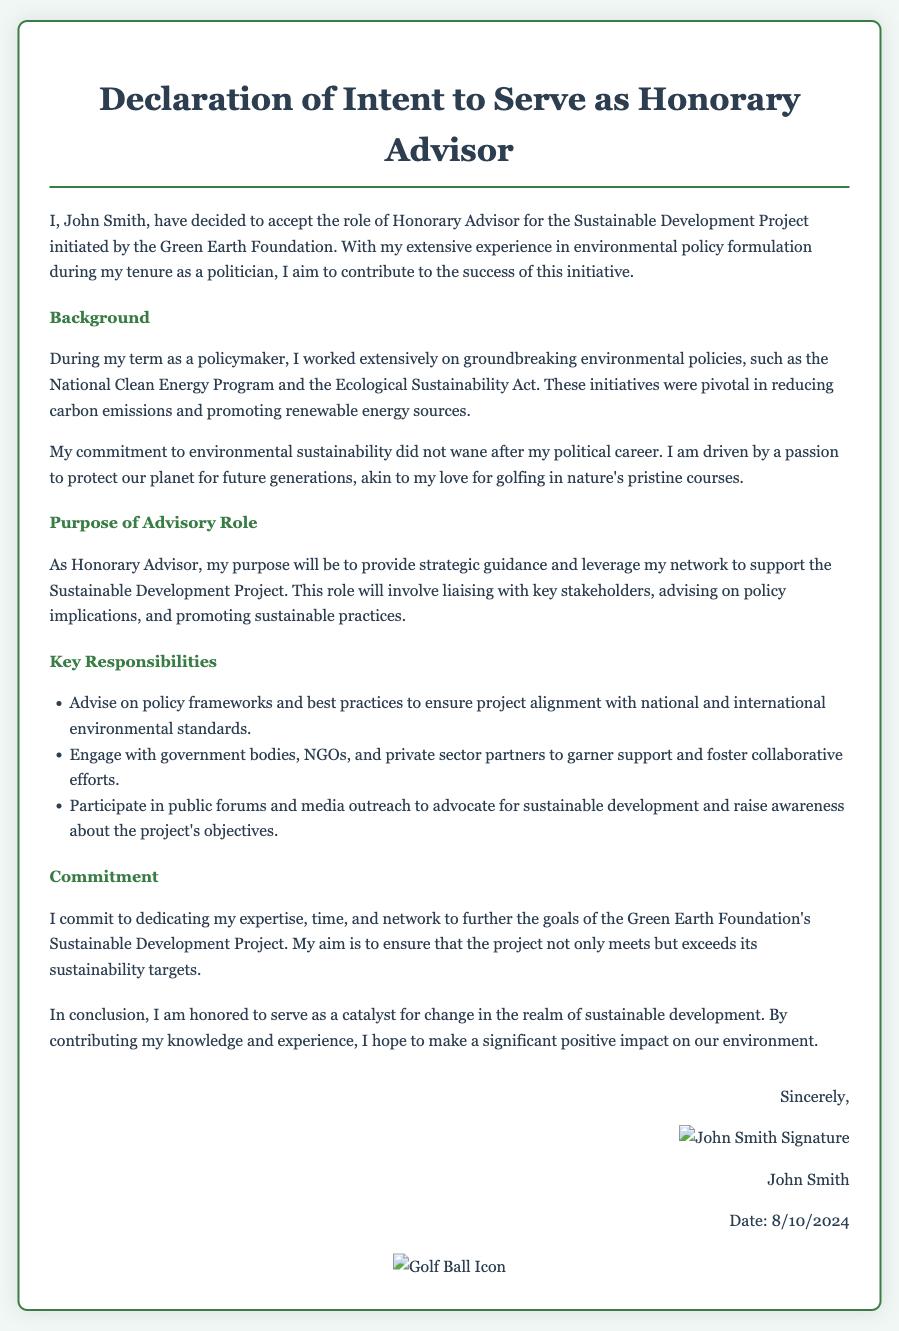What is the name of the individual accepting the role? The document explicitly states the individual as "John Smith," who is accepting the role of Honorary Advisor.
Answer: John Smith What organization initiated the Sustainable Development Project? The document mentions that the project is initiated by the "Green Earth Foundation."
Answer: Green Earth Foundation What are the key responsibilities listed in the document? One of the responsibilities includes advising on policy frameworks and best practices for environmental standards.
Answer: Advise on policy frameworks What is the date on the document? The current date is dynamically displayed by a script; however, it is meant to reflect the date the document is viewed.
Answer: [Current Date] What passion does the author express besides commitment to the environment? The author's passion for protecting the planet is compared to their love for golfing.
Answer: Golfing What does the author aim to ensure regarding the project's sustainability targets? The author explicitly states their aim to ensure that the project "not only meets but exceeds" its sustainability targets.
Answer: Exceeds its sustainability targets What is the primary purpose of the Honorary Advisor role? The document specifies that the primary purpose is to provide strategic guidance and leverage a network to support the project.
Answer: Provide strategic guidance Who is the intended audience for the public forums mentioned? The mention of public forums implies engagement with the general public and stakeholders concerned with sustainable development.
Answer: General public and stakeholders What does the author's commitment entail? The author's commitment involves dedicating expertise, time, and network to further the goals of the project.
Answer: Dedicate expertise, time, and network 